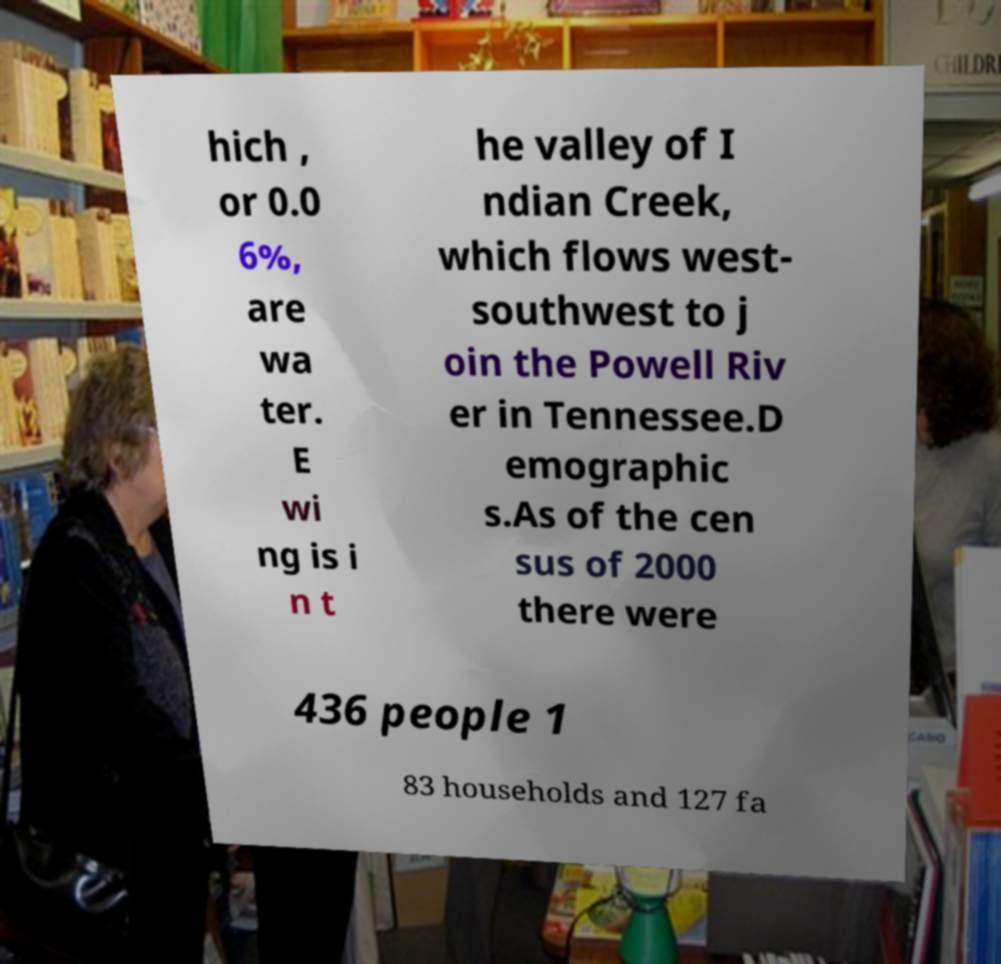Please read and relay the text visible in this image. What does it say? hich , or 0.0 6%, are wa ter. E wi ng is i n t he valley of I ndian Creek, which flows west- southwest to j oin the Powell Riv er in Tennessee.D emographic s.As of the cen sus of 2000 there were 436 people 1 83 households and 127 fa 